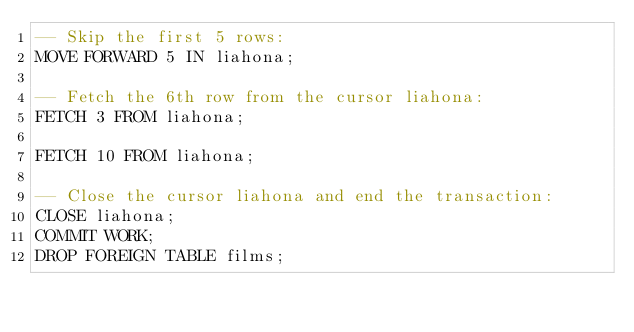Convert code to text. <code><loc_0><loc_0><loc_500><loc_500><_SQL_>-- Skip the first 5 rows:
MOVE FORWARD 5 IN liahona;

-- Fetch the 6th row from the cursor liahona:
FETCH 3 FROM liahona;

FETCH 10 FROM liahona;

-- Close the cursor liahona and end the transaction:
CLOSE liahona;
COMMIT WORK;
DROP FOREIGN TABLE films;
</code> 